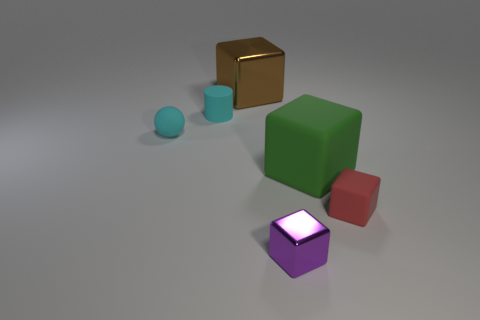There is a object that is the same color as the tiny ball; what is its shape?
Give a very brief answer. Cylinder. There is a object that is to the left of the small purple metallic block and in front of the cylinder; what is its shape?
Give a very brief answer. Sphere. There is a cyan thing that is made of the same material as the tiny cyan sphere; what is its shape?
Keep it short and to the point. Cylinder. What is the small cyan thing to the right of the cyan sphere made of?
Offer a very short reply. Rubber. Is the size of the metallic thing behind the green matte block the same as the metallic cube to the right of the brown block?
Ensure brevity in your answer.  No. What color is the small cylinder?
Give a very brief answer. Cyan. Do the big object that is right of the tiny metallic block and the large shiny object have the same shape?
Your answer should be compact. Yes. What is the small purple cube made of?
Ensure brevity in your answer.  Metal. There is a cyan object that is the same size as the cyan ball; what is its shape?
Your answer should be compact. Cylinder. Are there any tiny cylinders that have the same color as the small rubber sphere?
Your answer should be very brief. Yes. 